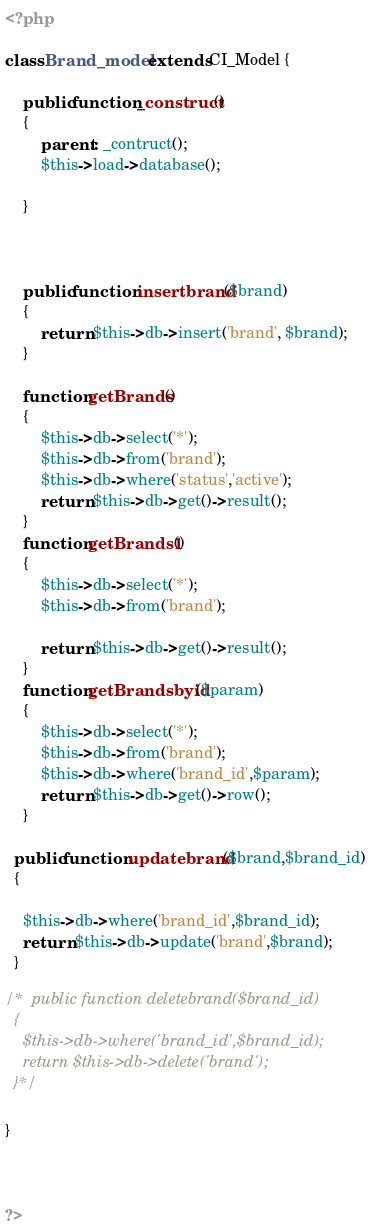<code> <loc_0><loc_0><loc_500><loc_500><_PHP_><?php

class Brand_model extends CI_Model {

	public function _construct()
	{
		parent:: _contruct();
		$this->load->database();

	}

	
	
	public function insertbrand($brand)
	{
		return $this->db->insert('brand', $brand);
	}

	function getBrands()
	{
		$this->db->select('*');
		$this->db->from('brand');
		$this->db->where('status','active');
		return $this->db->get()->result();
	}	
	function getBrands1()
	{
		$this->db->select('*');
		$this->db->from('brand');
		
		return $this->db->get()->result();
	}	
	function getBrandsbyid($param)
	{
		$this->db->select('*');
		$this->db->from('brand');
		$this->db->where('brand_id',$param);
		return $this->db->get()->row();
	}	

  public function updatebrand($brand,$brand_id)
  {
 
  	$this->db->where('brand_id',$brand_id);
  	return $this->db->update('brand',$brand);
  }

/*  public function deletebrand($brand_id)
  {
  	$this->db->where('brand_id',$brand_id);
  	return $this->db->delete('brand');
  }*/

}



?></code> 